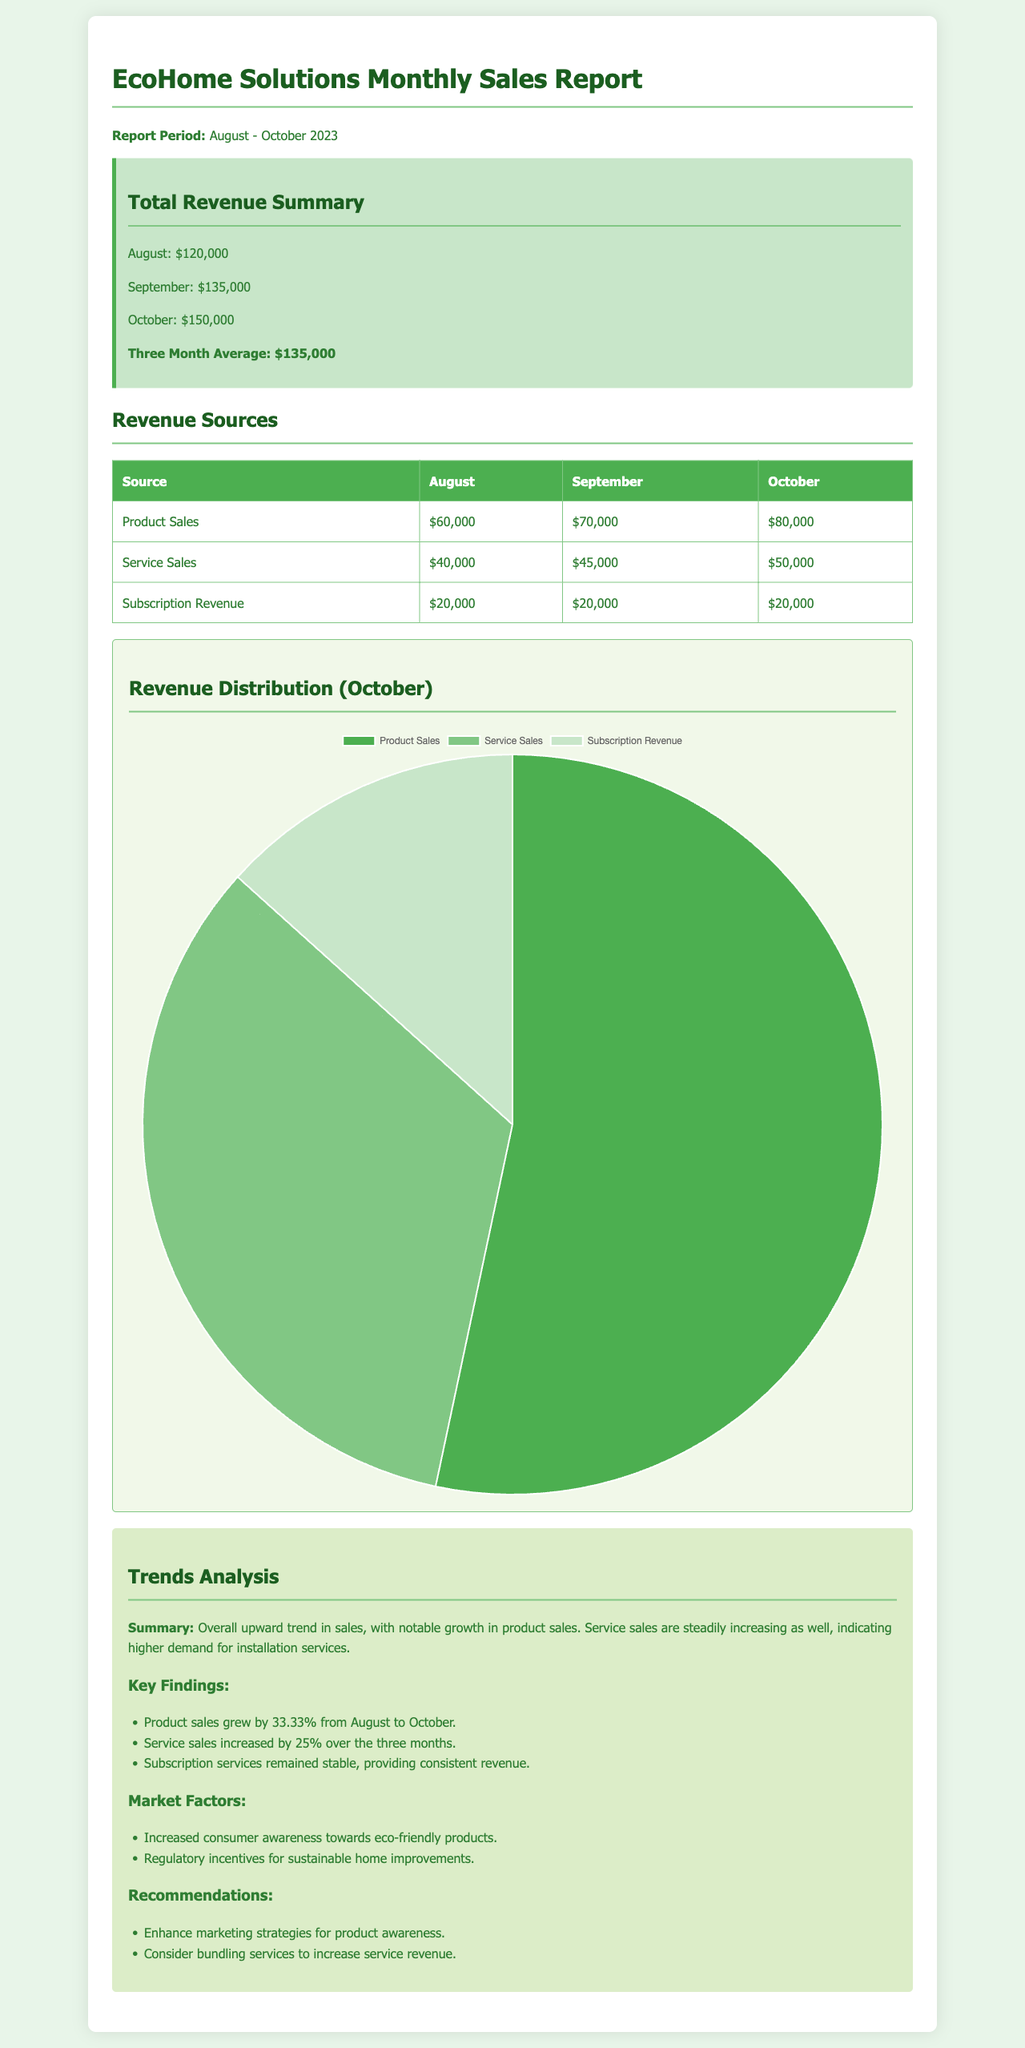What was the total revenue for October? The total revenue for October is explicitly stated in the document as $150,000.
Answer: $150,000 What is the revenue from Product Sales in September? The revenue from Product Sales in September is listed in the table as $70,000.
Answer: $70,000 How much did Service Sales increase from August to October? The Service Sales in August were $40,000 and in October were $50,000, showing an increase of $10,000 or 25%.
Answer: $10,000 What is the monthly average revenue over the three months? The document provides a summarized average of the total revenue for the past three months as $135,000.
Answer: $135,000 Which revenue source had the highest amount in October? The document shows that Product Sales had the highest revenue in October, amounting to $80,000.
Answer: Product Sales What percentage increase did Product Sales experience from August to October? The document indicates that Product Sales grew by 33.33% from August to October.
Answer: 33.33% What are the main factors affecting market trends according to the analysis? The document mentions increased consumer awareness towards eco-friendly products and regulatory incentives as key factors.
Answer: Consumer awareness and regulatory incentives What recommendation is made regarding service revenue? The recommendations include considering bundling services to increase service revenue.
Answer: Bundling services 